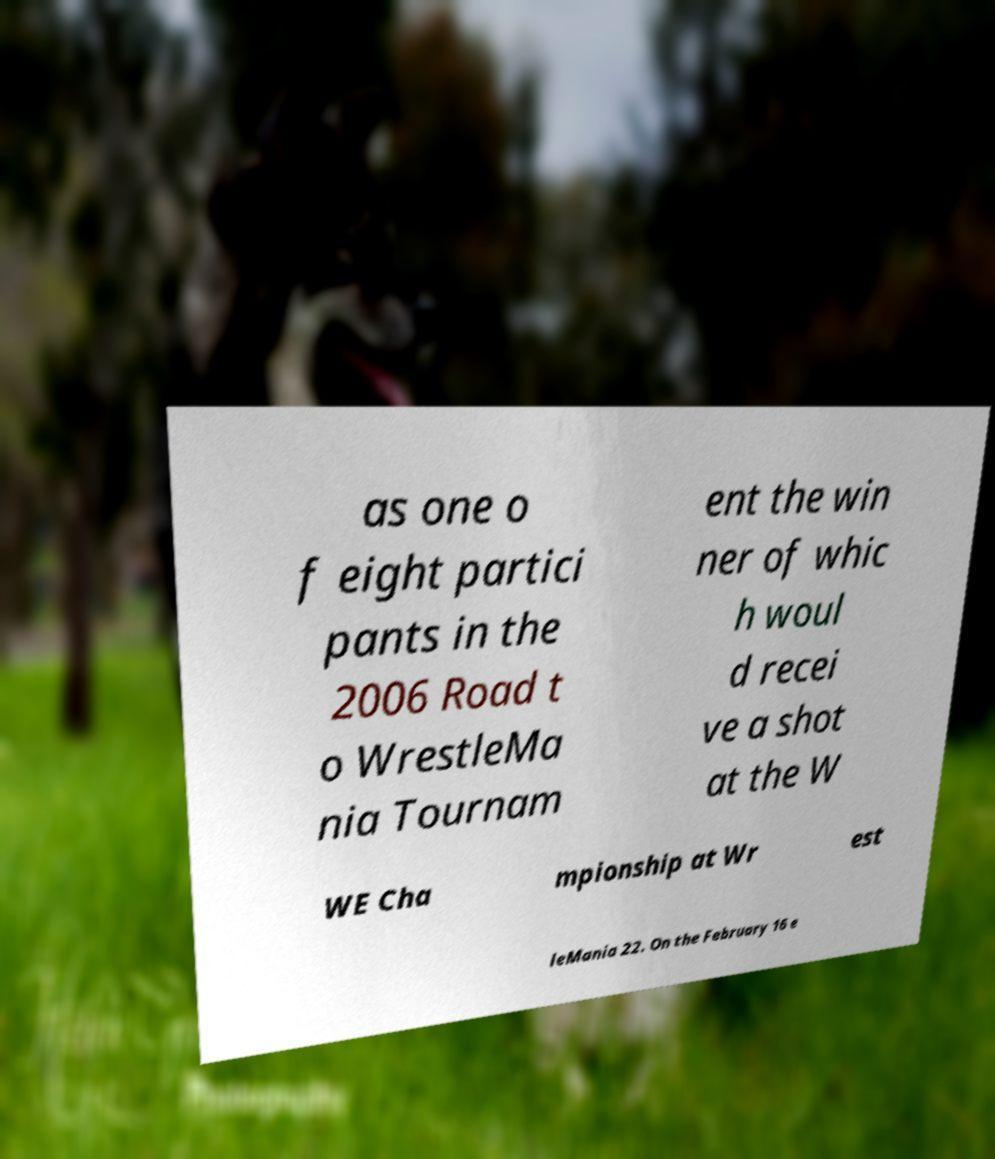Can you read and provide the text displayed in the image?This photo seems to have some interesting text. Can you extract and type it out for me? as one o f eight partici pants in the 2006 Road t o WrestleMa nia Tournam ent the win ner of whic h woul d recei ve a shot at the W WE Cha mpionship at Wr est leMania 22. On the February 16 e 